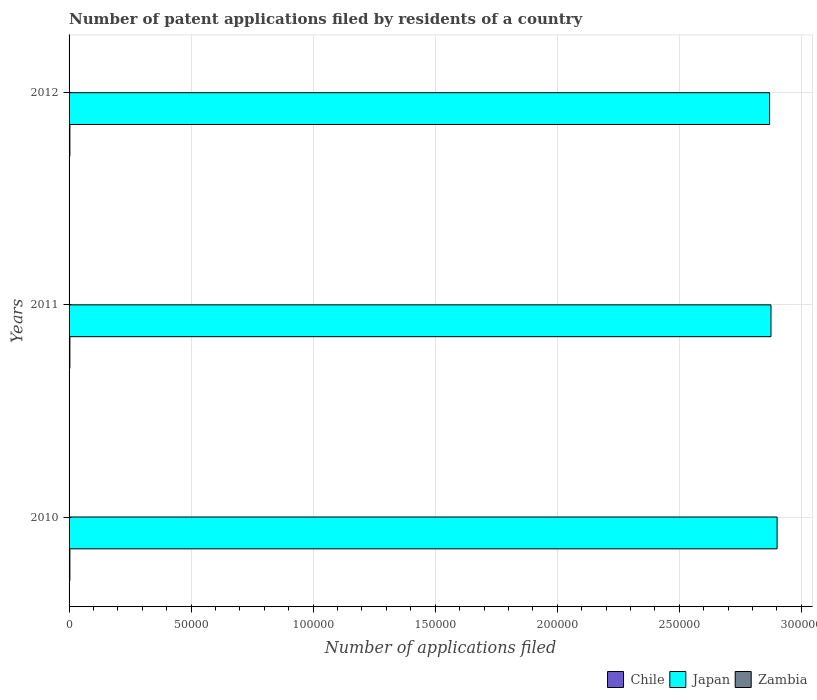How many groups of bars are there?
Offer a very short reply. 3. Are the number of bars on each tick of the Y-axis equal?
Your answer should be very brief. Yes. What is the label of the 2nd group of bars from the top?
Your answer should be compact. 2011. What is the number of applications filed in Chile in 2012?
Keep it short and to the point. 336. Across all years, what is the maximum number of applications filed in Chile?
Your answer should be very brief. 339. Across all years, what is the minimum number of applications filed in Chile?
Your answer should be compact. 328. In which year was the number of applications filed in Zambia maximum?
Your answer should be compact. 2012. In which year was the number of applications filed in Chile minimum?
Offer a terse response. 2010. What is the difference between the number of applications filed in Japan in 2011 and the number of applications filed in Zambia in 2012?
Provide a short and direct response. 2.88e+05. What is the average number of applications filed in Chile per year?
Your answer should be compact. 334.33. In the year 2011, what is the difference between the number of applications filed in Chile and number of applications filed in Zambia?
Give a very brief answer. 336. In how many years, is the number of applications filed in Zambia greater than 50000 ?
Your answer should be very brief. 0. What is the ratio of the number of applications filed in Japan in 2011 to that in 2012?
Provide a short and direct response. 1. Is the number of applications filed in Japan in 2010 less than that in 2011?
Your answer should be very brief. No. Is the difference between the number of applications filed in Chile in 2010 and 2011 greater than the difference between the number of applications filed in Zambia in 2010 and 2011?
Provide a succinct answer. No. What is the difference between the highest and the second highest number of applications filed in Chile?
Make the answer very short. 3. What does the 2nd bar from the top in 2012 represents?
Make the answer very short. Japan. Is it the case that in every year, the sum of the number of applications filed in Chile and number of applications filed in Zambia is greater than the number of applications filed in Japan?
Offer a very short reply. No. How many bars are there?
Make the answer very short. 9. Are the values on the major ticks of X-axis written in scientific E-notation?
Offer a terse response. No. Does the graph contain grids?
Your answer should be very brief. Yes. How many legend labels are there?
Offer a very short reply. 3. What is the title of the graph?
Ensure brevity in your answer.  Number of patent applications filed by residents of a country. What is the label or title of the X-axis?
Offer a very short reply. Number of applications filed. What is the label or title of the Y-axis?
Provide a succinct answer. Years. What is the Number of applications filed in Chile in 2010?
Make the answer very short. 328. What is the Number of applications filed in Japan in 2010?
Keep it short and to the point. 2.90e+05. What is the Number of applications filed in Chile in 2011?
Offer a very short reply. 339. What is the Number of applications filed in Japan in 2011?
Your response must be concise. 2.88e+05. What is the Number of applications filed in Zambia in 2011?
Your response must be concise. 3. What is the Number of applications filed of Chile in 2012?
Give a very brief answer. 336. What is the Number of applications filed of Japan in 2012?
Ensure brevity in your answer.  2.87e+05. Across all years, what is the maximum Number of applications filed of Chile?
Give a very brief answer. 339. Across all years, what is the maximum Number of applications filed in Japan?
Ensure brevity in your answer.  2.90e+05. Across all years, what is the minimum Number of applications filed in Chile?
Keep it short and to the point. 328. Across all years, what is the minimum Number of applications filed of Japan?
Offer a very short reply. 2.87e+05. Across all years, what is the minimum Number of applications filed in Zambia?
Offer a terse response. 3. What is the total Number of applications filed of Chile in the graph?
Your response must be concise. 1003. What is the total Number of applications filed in Japan in the graph?
Ensure brevity in your answer.  8.65e+05. What is the total Number of applications filed of Zambia in the graph?
Keep it short and to the point. 15. What is the difference between the Number of applications filed in Chile in 2010 and that in 2011?
Provide a succinct answer. -11. What is the difference between the Number of applications filed in Japan in 2010 and that in 2011?
Your response must be concise. 2501. What is the difference between the Number of applications filed in Zambia in 2010 and that in 2011?
Give a very brief answer. 2. What is the difference between the Number of applications filed of Chile in 2010 and that in 2012?
Your response must be concise. -8. What is the difference between the Number of applications filed of Japan in 2010 and that in 2012?
Provide a short and direct response. 3068. What is the difference between the Number of applications filed of Chile in 2011 and that in 2012?
Provide a short and direct response. 3. What is the difference between the Number of applications filed in Japan in 2011 and that in 2012?
Your answer should be compact. 567. What is the difference between the Number of applications filed of Chile in 2010 and the Number of applications filed of Japan in 2011?
Give a very brief answer. -2.87e+05. What is the difference between the Number of applications filed of Chile in 2010 and the Number of applications filed of Zambia in 2011?
Your answer should be very brief. 325. What is the difference between the Number of applications filed in Japan in 2010 and the Number of applications filed in Zambia in 2011?
Your answer should be compact. 2.90e+05. What is the difference between the Number of applications filed of Chile in 2010 and the Number of applications filed of Japan in 2012?
Your response must be concise. -2.87e+05. What is the difference between the Number of applications filed in Chile in 2010 and the Number of applications filed in Zambia in 2012?
Ensure brevity in your answer.  321. What is the difference between the Number of applications filed in Japan in 2010 and the Number of applications filed in Zambia in 2012?
Ensure brevity in your answer.  2.90e+05. What is the difference between the Number of applications filed of Chile in 2011 and the Number of applications filed of Japan in 2012?
Your answer should be very brief. -2.87e+05. What is the difference between the Number of applications filed of Chile in 2011 and the Number of applications filed of Zambia in 2012?
Make the answer very short. 332. What is the difference between the Number of applications filed in Japan in 2011 and the Number of applications filed in Zambia in 2012?
Keep it short and to the point. 2.88e+05. What is the average Number of applications filed in Chile per year?
Offer a terse response. 334.33. What is the average Number of applications filed in Japan per year?
Your response must be concise. 2.88e+05. In the year 2010, what is the difference between the Number of applications filed of Chile and Number of applications filed of Japan?
Ensure brevity in your answer.  -2.90e+05. In the year 2010, what is the difference between the Number of applications filed in Chile and Number of applications filed in Zambia?
Your answer should be compact. 323. In the year 2010, what is the difference between the Number of applications filed in Japan and Number of applications filed in Zambia?
Offer a terse response. 2.90e+05. In the year 2011, what is the difference between the Number of applications filed of Chile and Number of applications filed of Japan?
Make the answer very short. -2.87e+05. In the year 2011, what is the difference between the Number of applications filed in Chile and Number of applications filed in Zambia?
Your response must be concise. 336. In the year 2011, what is the difference between the Number of applications filed of Japan and Number of applications filed of Zambia?
Your answer should be compact. 2.88e+05. In the year 2012, what is the difference between the Number of applications filed in Chile and Number of applications filed in Japan?
Provide a succinct answer. -2.87e+05. In the year 2012, what is the difference between the Number of applications filed of Chile and Number of applications filed of Zambia?
Your answer should be very brief. 329. In the year 2012, what is the difference between the Number of applications filed of Japan and Number of applications filed of Zambia?
Provide a short and direct response. 2.87e+05. What is the ratio of the Number of applications filed in Chile in 2010 to that in 2011?
Your answer should be very brief. 0.97. What is the ratio of the Number of applications filed in Japan in 2010 to that in 2011?
Offer a terse response. 1.01. What is the ratio of the Number of applications filed in Zambia in 2010 to that in 2011?
Offer a terse response. 1.67. What is the ratio of the Number of applications filed in Chile in 2010 to that in 2012?
Your answer should be compact. 0.98. What is the ratio of the Number of applications filed in Japan in 2010 to that in 2012?
Give a very brief answer. 1.01. What is the ratio of the Number of applications filed in Chile in 2011 to that in 2012?
Your answer should be compact. 1.01. What is the ratio of the Number of applications filed of Japan in 2011 to that in 2012?
Your response must be concise. 1. What is the ratio of the Number of applications filed of Zambia in 2011 to that in 2012?
Offer a terse response. 0.43. What is the difference between the highest and the second highest Number of applications filed of Chile?
Ensure brevity in your answer.  3. What is the difference between the highest and the second highest Number of applications filed of Japan?
Provide a succinct answer. 2501. What is the difference between the highest and the lowest Number of applications filed in Japan?
Make the answer very short. 3068. What is the difference between the highest and the lowest Number of applications filed in Zambia?
Offer a very short reply. 4. 